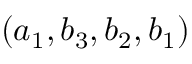<formula> <loc_0><loc_0><loc_500><loc_500>( a _ { 1 } , b _ { 3 } , b _ { 2 } , b _ { 1 } )</formula> 